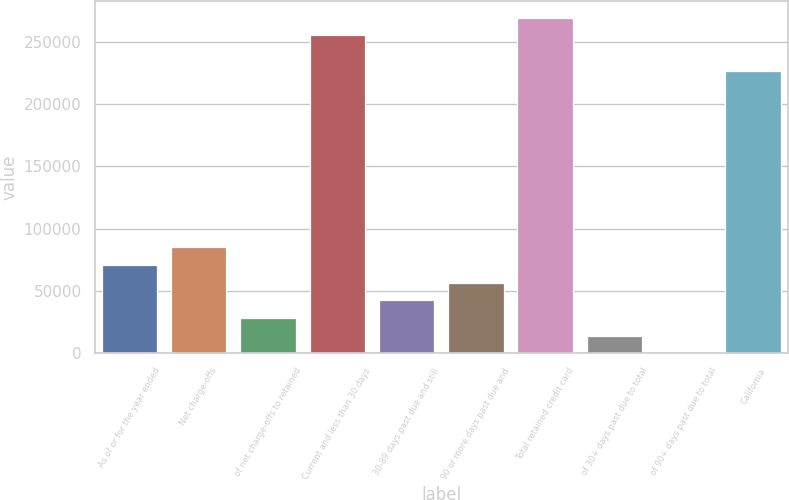Convert chart. <chart><loc_0><loc_0><loc_500><loc_500><bar_chart><fcel>As of or for the year ended<fcel>Net charge-offs<fcel>of net charge-offs to retained<fcel>Current and less than 30 days<fcel>30-89 days past due and still<fcel>90 or more days past due and<fcel>Total retained credit card<fcel>of 30+ days past due to total<fcel>of 90+ days past due to total<fcel>California<nl><fcel>70855.9<fcel>85026.9<fcel>28342.8<fcel>255079<fcel>42513.9<fcel>56684.9<fcel>269250<fcel>14171.8<fcel>0.81<fcel>226737<nl></chart> 